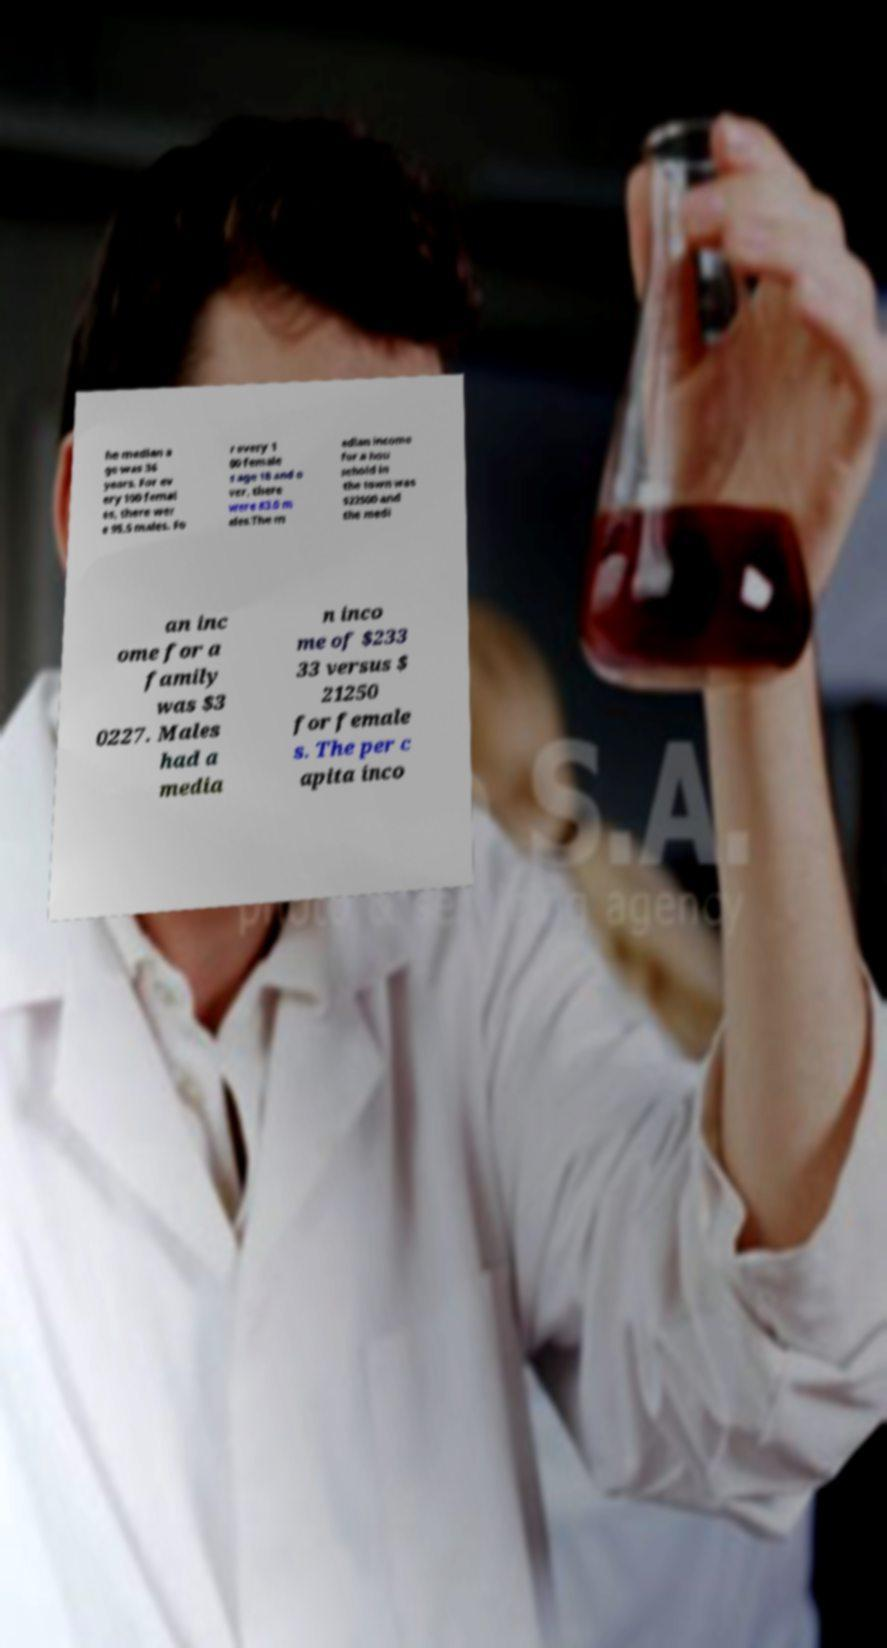Please identify and transcribe the text found in this image. he median a ge was 36 years. For ev ery 100 femal es, there wer e 95.5 males. Fo r every 1 00 female s age 18 and o ver, there were 83.0 m ales.The m edian income for a hou sehold in the town was $22500 and the medi an inc ome for a family was $3 0227. Males had a media n inco me of $233 33 versus $ 21250 for female s. The per c apita inco 